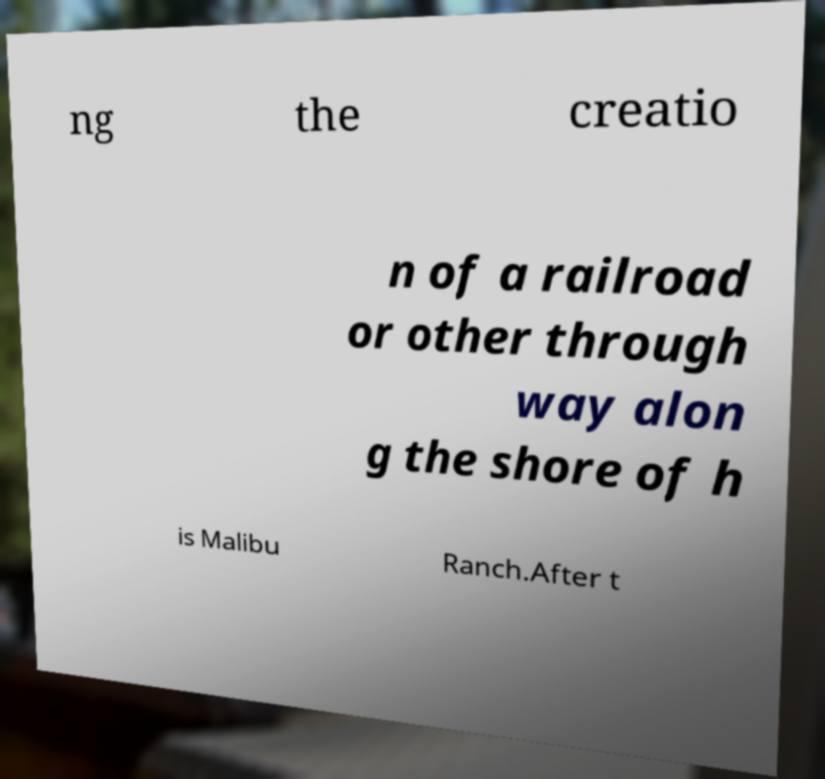For documentation purposes, I need the text within this image transcribed. Could you provide that? ng the creatio n of a railroad or other through way alon g the shore of h is Malibu Ranch.After t 